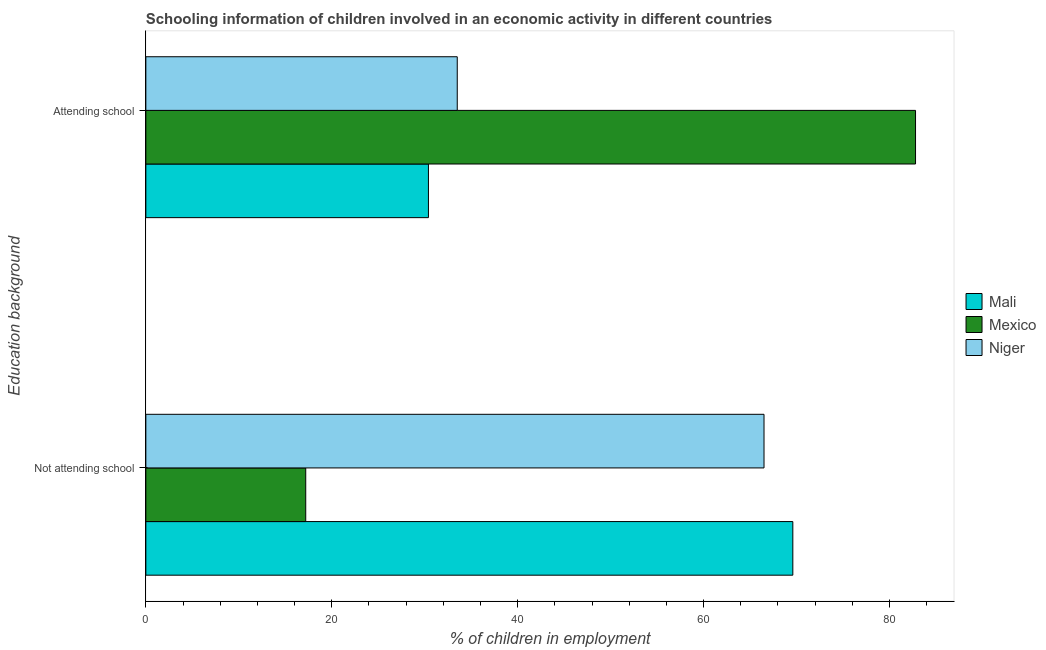What is the label of the 2nd group of bars from the top?
Your answer should be compact. Not attending school. What is the percentage of employed children who are not attending school in Mexico?
Keep it short and to the point. 17.2. Across all countries, what is the maximum percentage of employed children who are attending school?
Ensure brevity in your answer.  82.8. Across all countries, what is the minimum percentage of employed children who are attending school?
Keep it short and to the point. 30.4. In which country was the percentage of employed children who are not attending school maximum?
Provide a succinct answer. Mali. What is the total percentage of employed children who are attending school in the graph?
Give a very brief answer. 146.7. What is the difference between the percentage of employed children who are attending school in Niger and that in Mali?
Provide a succinct answer. 3.1. What is the difference between the percentage of employed children who are not attending school in Niger and the percentage of employed children who are attending school in Mali?
Your answer should be very brief. 36.1. What is the average percentage of employed children who are not attending school per country?
Keep it short and to the point. 51.1. What is the difference between the percentage of employed children who are not attending school and percentage of employed children who are attending school in Mali?
Give a very brief answer. 39.2. What is the ratio of the percentage of employed children who are attending school in Mexico to that in Mali?
Ensure brevity in your answer.  2.72. Is the percentage of employed children who are not attending school in Mexico less than that in Mali?
Ensure brevity in your answer.  Yes. In how many countries, is the percentage of employed children who are not attending school greater than the average percentage of employed children who are not attending school taken over all countries?
Provide a short and direct response. 2. What does the 3rd bar from the top in Attending school represents?
Ensure brevity in your answer.  Mali. How many bars are there?
Offer a terse response. 6. What is the difference between two consecutive major ticks on the X-axis?
Provide a succinct answer. 20. Are the values on the major ticks of X-axis written in scientific E-notation?
Your answer should be compact. No. Does the graph contain any zero values?
Your answer should be compact. No. How many legend labels are there?
Make the answer very short. 3. What is the title of the graph?
Your response must be concise. Schooling information of children involved in an economic activity in different countries. What is the label or title of the X-axis?
Ensure brevity in your answer.  % of children in employment. What is the label or title of the Y-axis?
Offer a very short reply. Education background. What is the % of children in employment in Mali in Not attending school?
Ensure brevity in your answer.  69.6. What is the % of children in employment in Mexico in Not attending school?
Your response must be concise. 17.2. What is the % of children in employment of Niger in Not attending school?
Keep it short and to the point. 66.5. What is the % of children in employment in Mali in Attending school?
Your response must be concise. 30.4. What is the % of children in employment of Mexico in Attending school?
Provide a short and direct response. 82.8. What is the % of children in employment in Niger in Attending school?
Provide a succinct answer. 33.5. Across all Education background, what is the maximum % of children in employment of Mali?
Make the answer very short. 69.6. Across all Education background, what is the maximum % of children in employment of Mexico?
Offer a terse response. 82.8. Across all Education background, what is the maximum % of children in employment in Niger?
Give a very brief answer. 66.5. Across all Education background, what is the minimum % of children in employment of Mali?
Provide a succinct answer. 30.4. Across all Education background, what is the minimum % of children in employment of Mexico?
Ensure brevity in your answer.  17.2. Across all Education background, what is the minimum % of children in employment of Niger?
Give a very brief answer. 33.5. What is the total % of children in employment of Mexico in the graph?
Your response must be concise. 100. What is the difference between the % of children in employment in Mali in Not attending school and that in Attending school?
Provide a succinct answer. 39.2. What is the difference between the % of children in employment of Mexico in Not attending school and that in Attending school?
Ensure brevity in your answer.  -65.6. What is the difference between the % of children in employment of Niger in Not attending school and that in Attending school?
Offer a terse response. 33. What is the difference between the % of children in employment in Mali in Not attending school and the % of children in employment in Niger in Attending school?
Ensure brevity in your answer.  36.1. What is the difference between the % of children in employment of Mexico in Not attending school and the % of children in employment of Niger in Attending school?
Offer a very short reply. -16.3. What is the difference between the % of children in employment in Mali and % of children in employment in Mexico in Not attending school?
Provide a succinct answer. 52.4. What is the difference between the % of children in employment in Mali and % of children in employment in Niger in Not attending school?
Offer a very short reply. 3.1. What is the difference between the % of children in employment in Mexico and % of children in employment in Niger in Not attending school?
Your response must be concise. -49.3. What is the difference between the % of children in employment in Mali and % of children in employment in Mexico in Attending school?
Give a very brief answer. -52.4. What is the difference between the % of children in employment of Mali and % of children in employment of Niger in Attending school?
Your answer should be compact. -3.1. What is the difference between the % of children in employment of Mexico and % of children in employment of Niger in Attending school?
Provide a short and direct response. 49.3. What is the ratio of the % of children in employment of Mali in Not attending school to that in Attending school?
Provide a succinct answer. 2.29. What is the ratio of the % of children in employment of Mexico in Not attending school to that in Attending school?
Ensure brevity in your answer.  0.21. What is the ratio of the % of children in employment of Niger in Not attending school to that in Attending school?
Make the answer very short. 1.99. What is the difference between the highest and the second highest % of children in employment of Mali?
Offer a terse response. 39.2. What is the difference between the highest and the second highest % of children in employment in Mexico?
Your answer should be very brief. 65.6. What is the difference between the highest and the lowest % of children in employment in Mali?
Provide a short and direct response. 39.2. What is the difference between the highest and the lowest % of children in employment in Mexico?
Make the answer very short. 65.6. What is the difference between the highest and the lowest % of children in employment of Niger?
Give a very brief answer. 33. 